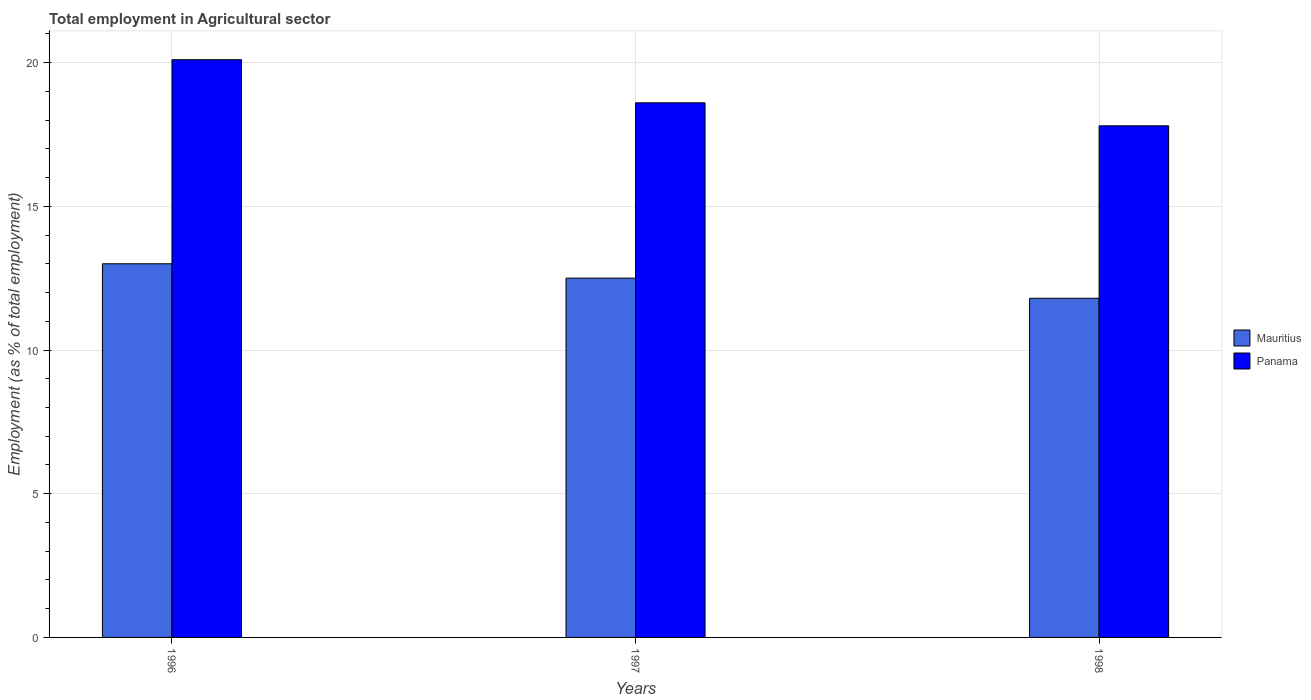How many different coloured bars are there?
Give a very brief answer. 2. Are the number of bars on each tick of the X-axis equal?
Provide a succinct answer. Yes. How many bars are there on the 3rd tick from the left?
Give a very brief answer. 2. What is the label of the 3rd group of bars from the left?
Offer a very short reply. 1998. What is the employment in agricultural sector in Mauritius in 1998?
Provide a succinct answer. 11.8. Across all years, what is the maximum employment in agricultural sector in Mauritius?
Your response must be concise. 13. Across all years, what is the minimum employment in agricultural sector in Mauritius?
Offer a terse response. 11.8. In which year was the employment in agricultural sector in Panama minimum?
Provide a succinct answer. 1998. What is the total employment in agricultural sector in Mauritius in the graph?
Your response must be concise. 37.3. What is the difference between the employment in agricultural sector in Mauritius in 1997 and that in 1998?
Give a very brief answer. 0.7. What is the difference between the employment in agricultural sector in Panama in 1997 and the employment in agricultural sector in Mauritius in 1996?
Provide a short and direct response. 5.6. What is the average employment in agricultural sector in Panama per year?
Offer a terse response. 18.83. In the year 1998, what is the difference between the employment in agricultural sector in Mauritius and employment in agricultural sector in Panama?
Provide a short and direct response. -6. What is the ratio of the employment in agricultural sector in Mauritius in 1997 to that in 1998?
Offer a very short reply. 1.06. Is the difference between the employment in agricultural sector in Mauritius in 1996 and 1998 greater than the difference between the employment in agricultural sector in Panama in 1996 and 1998?
Your answer should be very brief. No. What is the difference between the highest and the second highest employment in agricultural sector in Mauritius?
Make the answer very short. 0.5. What is the difference between the highest and the lowest employment in agricultural sector in Panama?
Your answer should be very brief. 2.3. Is the sum of the employment in agricultural sector in Mauritius in 1996 and 1997 greater than the maximum employment in agricultural sector in Panama across all years?
Provide a short and direct response. Yes. What does the 2nd bar from the left in 1997 represents?
Provide a succinct answer. Panama. What does the 1st bar from the right in 1996 represents?
Provide a succinct answer. Panama. How many bars are there?
Offer a very short reply. 6. Are all the bars in the graph horizontal?
Provide a succinct answer. No. How many years are there in the graph?
Offer a very short reply. 3. What is the difference between two consecutive major ticks on the Y-axis?
Provide a short and direct response. 5. Are the values on the major ticks of Y-axis written in scientific E-notation?
Keep it short and to the point. No. Where does the legend appear in the graph?
Provide a succinct answer. Center right. What is the title of the graph?
Your response must be concise. Total employment in Agricultural sector. What is the label or title of the X-axis?
Make the answer very short. Years. What is the label or title of the Y-axis?
Provide a succinct answer. Employment (as % of total employment). What is the Employment (as % of total employment) of Panama in 1996?
Provide a short and direct response. 20.1. What is the Employment (as % of total employment) in Mauritius in 1997?
Offer a very short reply. 12.5. What is the Employment (as % of total employment) of Panama in 1997?
Offer a very short reply. 18.6. What is the Employment (as % of total employment) in Mauritius in 1998?
Offer a terse response. 11.8. What is the Employment (as % of total employment) of Panama in 1998?
Your response must be concise. 17.8. Across all years, what is the maximum Employment (as % of total employment) of Mauritius?
Provide a succinct answer. 13. Across all years, what is the maximum Employment (as % of total employment) in Panama?
Provide a short and direct response. 20.1. Across all years, what is the minimum Employment (as % of total employment) in Mauritius?
Your answer should be compact. 11.8. Across all years, what is the minimum Employment (as % of total employment) of Panama?
Ensure brevity in your answer.  17.8. What is the total Employment (as % of total employment) in Mauritius in the graph?
Your answer should be compact. 37.3. What is the total Employment (as % of total employment) in Panama in the graph?
Provide a short and direct response. 56.5. What is the difference between the Employment (as % of total employment) of Mauritius in 1996 and that in 1997?
Keep it short and to the point. 0.5. What is the difference between the Employment (as % of total employment) of Mauritius in 1997 and that in 1998?
Offer a terse response. 0.7. What is the difference between the Employment (as % of total employment) in Mauritius in 1996 and the Employment (as % of total employment) in Panama in 1998?
Keep it short and to the point. -4.8. What is the difference between the Employment (as % of total employment) of Mauritius in 1997 and the Employment (as % of total employment) of Panama in 1998?
Make the answer very short. -5.3. What is the average Employment (as % of total employment) of Mauritius per year?
Offer a terse response. 12.43. What is the average Employment (as % of total employment) of Panama per year?
Keep it short and to the point. 18.83. In the year 1996, what is the difference between the Employment (as % of total employment) of Mauritius and Employment (as % of total employment) of Panama?
Offer a very short reply. -7.1. In the year 1997, what is the difference between the Employment (as % of total employment) of Mauritius and Employment (as % of total employment) of Panama?
Ensure brevity in your answer.  -6.1. What is the ratio of the Employment (as % of total employment) in Mauritius in 1996 to that in 1997?
Your answer should be compact. 1.04. What is the ratio of the Employment (as % of total employment) of Panama in 1996 to that in 1997?
Give a very brief answer. 1.08. What is the ratio of the Employment (as % of total employment) in Mauritius in 1996 to that in 1998?
Your answer should be compact. 1.1. What is the ratio of the Employment (as % of total employment) in Panama in 1996 to that in 1998?
Make the answer very short. 1.13. What is the ratio of the Employment (as % of total employment) in Mauritius in 1997 to that in 1998?
Offer a very short reply. 1.06. What is the ratio of the Employment (as % of total employment) of Panama in 1997 to that in 1998?
Give a very brief answer. 1.04. What is the difference between the highest and the lowest Employment (as % of total employment) of Panama?
Provide a succinct answer. 2.3. 